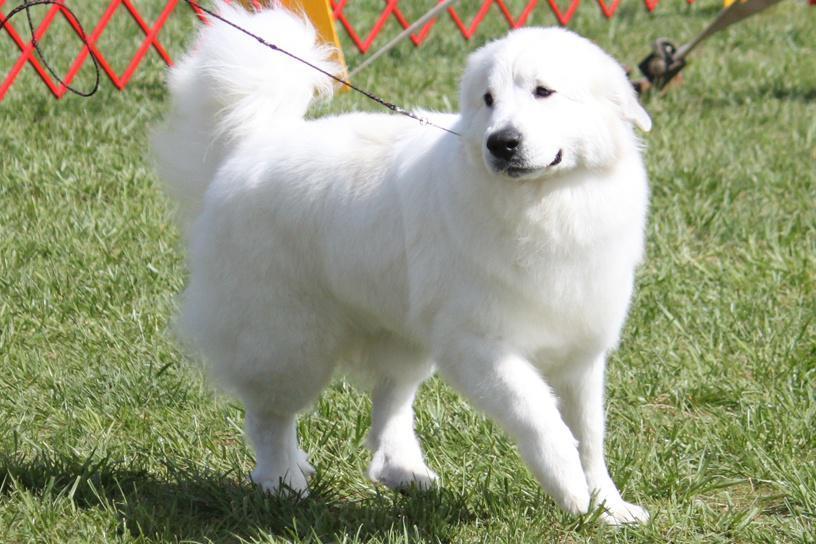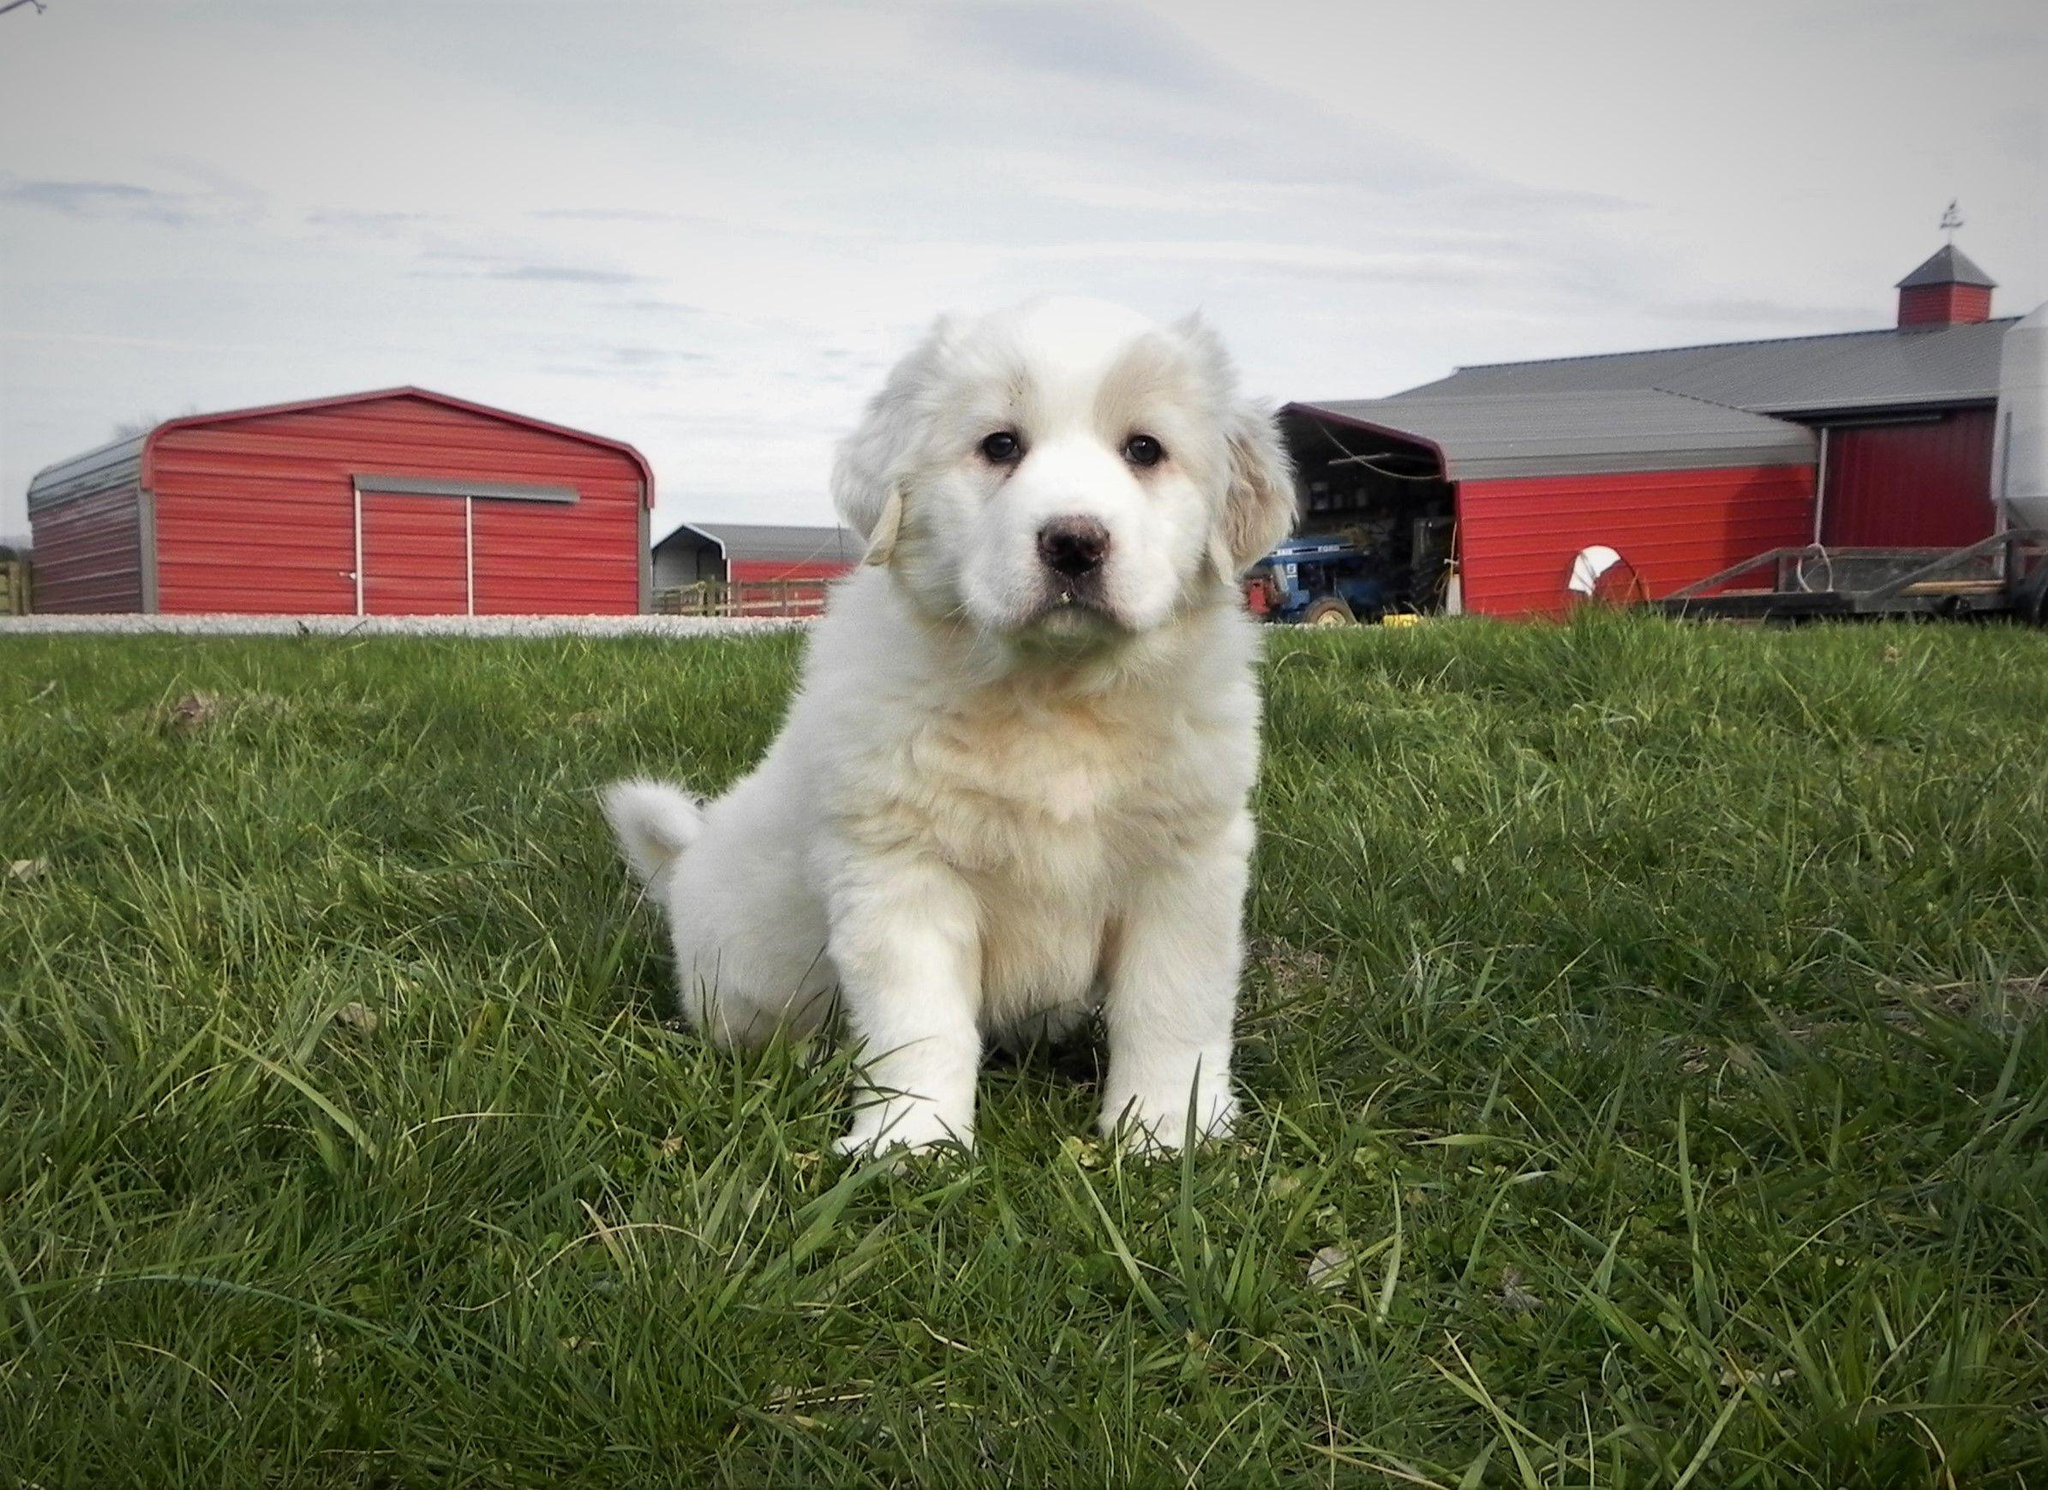The first image is the image on the left, the second image is the image on the right. Assess this claim about the two images: "Each image shows one dog which is standing on all fours.". Correct or not? Answer yes or no. No. 